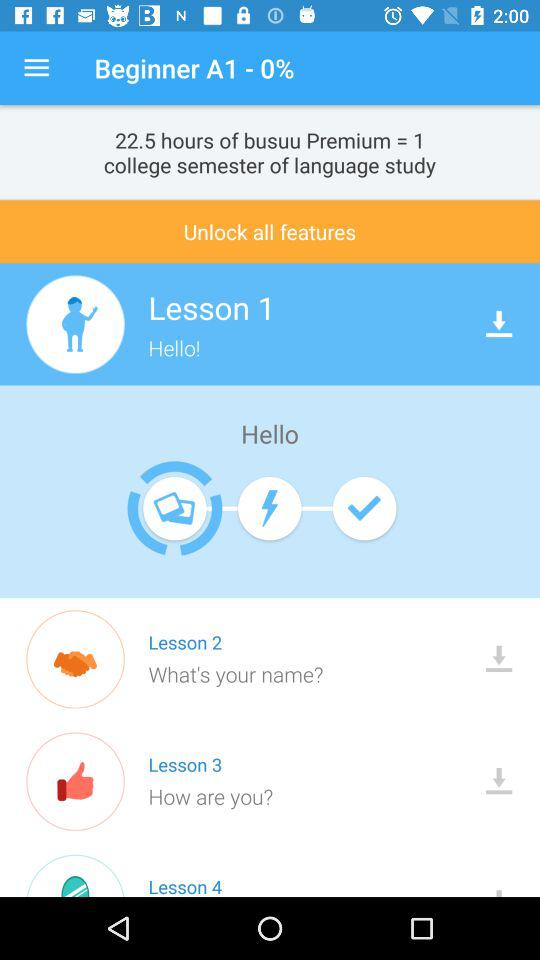How many lessons are there in total?
Answer the question using a single word or phrase. 4 